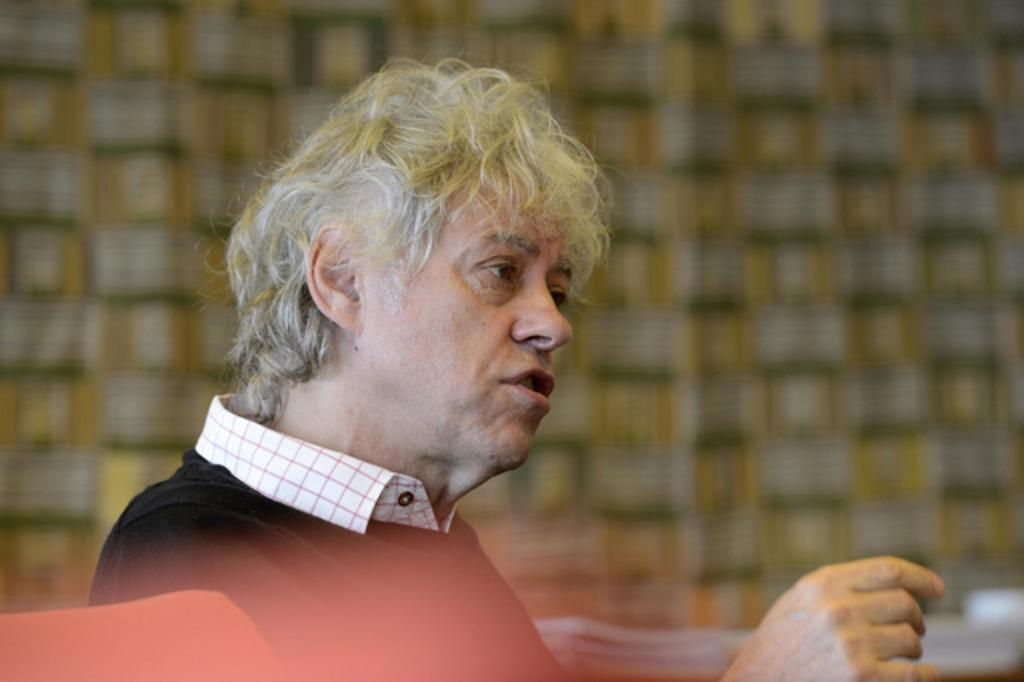What is the main subject of the image? There is a man in the image. What is the man doing in the image? The man is sitting. What type of cover is the man holding in the image? There is no cover present in the image; the man is simply sitting. Can you see a locket around the man's neck in the image? There is no mention of a locket in the provided facts, so it cannot be determined if one is present. 